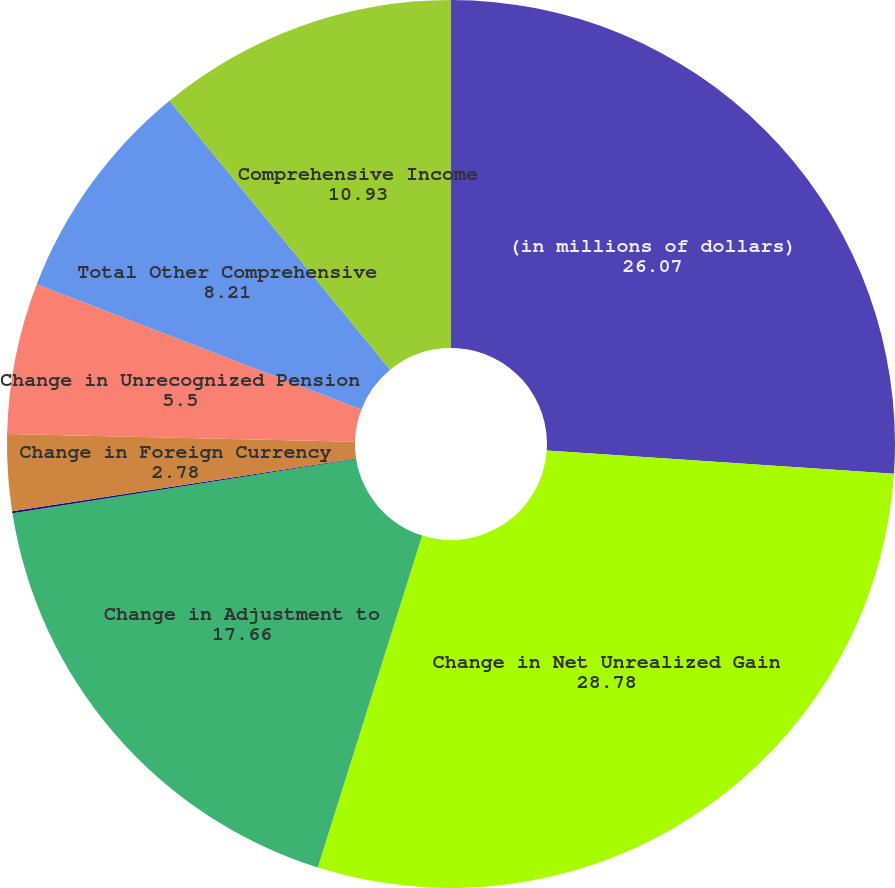Convert chart to OTSL. <chart><loc_0><loc_0><loc_500><loc_500><pie_chart><fcel>(in millions of dollars)<fcel>Change in Net Unrealized Gain<fcel>Change in Adjustment to<fcel>Change in Net Gain on Cash<fcel>Change in Foreign Currency<fcel>Change in Unrecognized Pension<fcel>Total Other Comprehensive<fcel>Comprehensive Income<nl><fcel>26.07%<fcel>28.78%<fcel>17.66%<fcel>0.07%<fcel>2.78%<fcel>5.5%<fcel>8.21%<fcel>10.93%<nl></chart> 